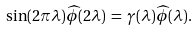<formula> <loc_0><loc_0><loc_500><loc_500>\sin ( 2 \pi \lambda ) \widehat { \phi } ( 2 \lambda ) \, = \, \gamma ( \lambda ) \widehat { \phi } ( \lambda ) .</formula> 